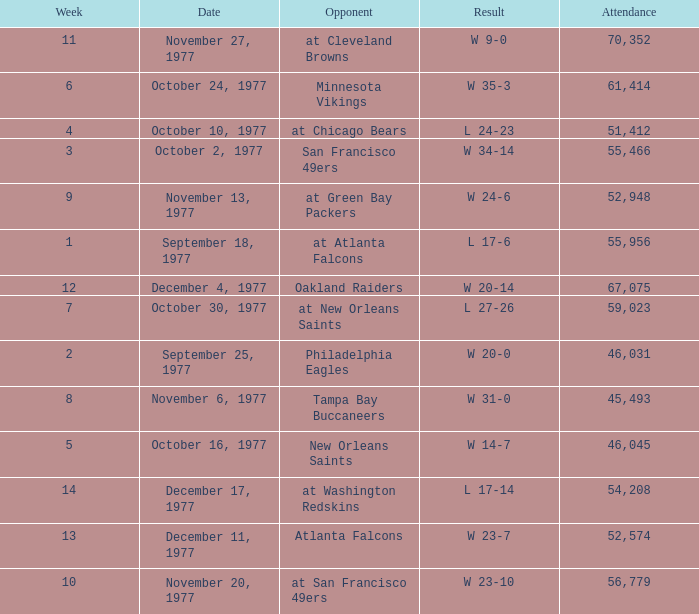What is the lowest attendance for week 2? 46031.0. Could you parse the entire table as a dict? {'header': ['Week', 'Date', 'Opponent', 'Result', 'Attendance'], 'rows': [['11', 'November 27, 1977', 'at Cleveland Browns', 'W 9-0', '70,352'], ['6', 'October 24, 1977', 'Minnesota Vikings', 'W 35-3', '61,414'], ['4', 'October 10, 1977', 'at Chicago Bears', 'L 24-23', '51,412'], ['3', 'October 2, 1977', 'San Francisco 49ers', 'W 34-14', '55,466'], ['9', 'November 13, 1977', 'at Green Bay Packers', 'W 24-6', '52,948'], ['1', 'September 18, 1977', 'at Atlanta Falcons', 'L 17-6', '55,956'], ['12', 'December 4, 1977', 'Oakland Raiders', 'W 20-14', '67,075'], ['7', 'October 30, 1977', 'at New Orleans Saints', 'L 27-26', '59,023'], ['2', 'September 25, 1977', 'Philadelphia Eagles', 'W 20-0', '46,031'], ['8', 'November 6, 1977', 'Tampa Bay Buccaneers', 'W 31-0', '45,493'], ['5', 'October 16, 1977', 'New Orleans Saints', 'W 14-7', '46,045'], ['14', 'December 17, 1977', 'at Washington Redskins', 'L 17-14', '54,208'], ['13', 'December 11, 1977', 'Atlanta Falcons', 'W 23-7', '52,574'], ['10', 'November 20, 1977', 'at San Francisco 49ers', 'W 23-10', '56,779']]} 